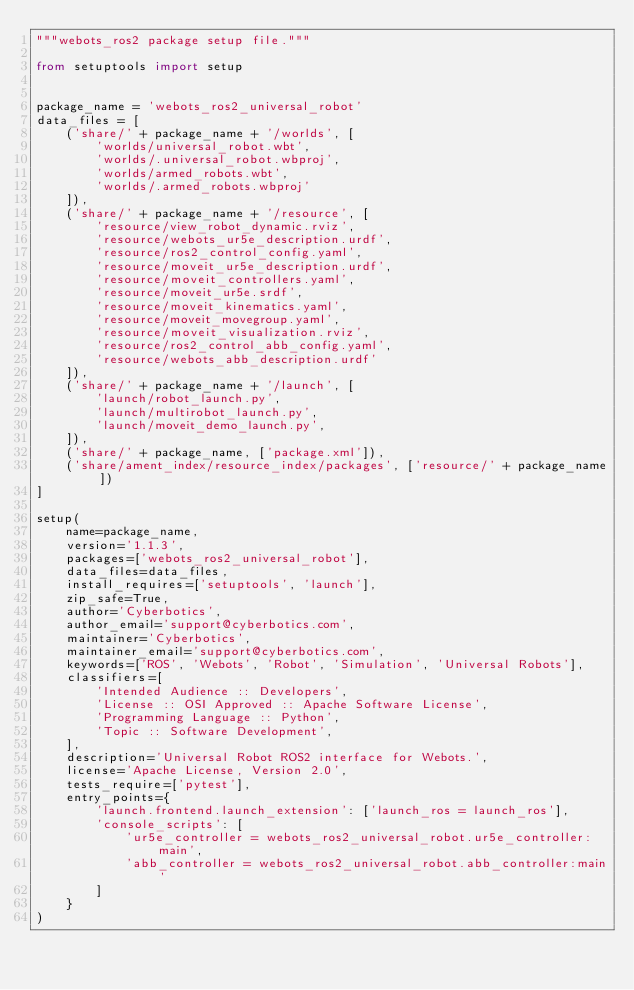<code> <loc_0><loc_0><loc_500><loc_500><_Python_>"""webots_ros2 package setup file."""

from setuptools import setup


package_name = 'webots_ros2_universal_robot'
data_files = [
    ('share/' + package_name + '/worlds', [
        'worlds/universal_robot.wbt',
        'worlds/.universal_robot.wbproj',
        'worlds/armed_robots.wbt',
        'worlds/.armed_robots.wbproj'
    ]),
    ('share/' + package_name + '/resource', [
        'resource/view_robot_dynamic.rviz',
        'resource/webots_ur5e_description.urdf',
        'resource/ros2_control_config.yaml',
        'resource/moveit_ur5e_description.urdf',
        'resource/moveit_controllers.yaml',
        'resource/moveit_ur5e.srdf',
        'resource/moveit_kinematics.yaml',
        'resource/moveit_movegroup.yaml',
        'resource/moveit_visualization.rviz',
        'resource/ros2_control_abb_config.yaml',
        'resource/webots_abb_description.urdf'
    ]),
    ('share/' + package_name + '/launch', [
        'launch/robot_launch.py',
        'launch/multirobot_launch.py',
        'launch/moveit_demo_launch.py',
    ]),
    ('share/' + package_name, ['package.xml']),
    ('share/ament_index/resource_index/packages', ['resource/' + package_name])
]

setup(
    name=package_name,
    version='1.1.3',
    packages=['webots_ros2_universal_robot'],
    data_files=data_files,
    install_requires=['setuptools', 'launch'],
    zip_safe=True,
    author='Cyberbotics',
    author_email='support@cyberbotics.com',
    maintainer='Cyberbotics',
    maintainer_email='support@cyberbotics.com',
    keywords=['ROS', 'Webots', 'Robot', 'Simulation', 'Universal Robots'],
    classifiers=[
        'Intended Audience :: Developers',
        'License :: OSI Approved :: Apache Software License',
        'Programming Language :: Python',
        'Topic :: Software Development',
    ],
    description='Universal Robot ROS2 interface for Webots.',
    license='Apache License, Version 2.0',
    tests_require=['pytest'],
    entry_points={
        'launch.frontend.launch_extension': ['launch_ros = launch_ros'],
        'console_scripts': [
            'ur5e_controller = webots_ros2_universal_robot.ur5e_controller:main',
            'abb_controller = webots_ros2_universal_robot.abb_controller:main'
        ]
    }
)
</code> 